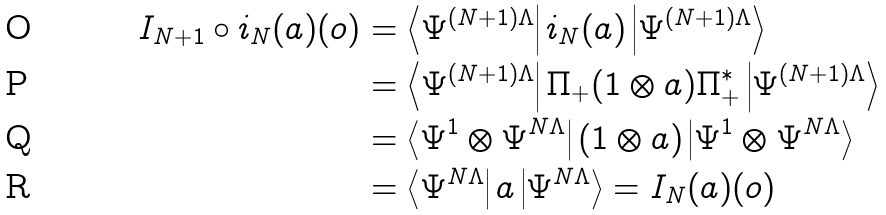<formula> <loc_0><loc_0><loc_500><loc_500>I _ { N + 1 } \circ i _ { N } ( a ) ( o ) & = \left < \Psi ^ { ( N + 1 ) \Lambda } \right | i _ { N } ( a ) \left | \Psi ^ { ( N + 1 ) \Lambda } \right > \\ & = \left < \Psi ^ { ( N + 1 ) \Lambda } \right | \Pi _ { + } ( 1 \otimes a ) \Pi _ { + } ^ { * } \left | \Psi ^ { ( N + 1 ) \Lambda } \right > \\ & = \left < \Psi ^ { 1 } \otimes \Psi ^ { N \Lambda } \right | ( 1 \otimes a ) \left | \Psi ^ { 1 } \otimes \Psi ^ { N \Lambda } \right > \\ & = \left < \Psi ^ { N \Lambda } \right | a \left | \Psi ^ { N \Lambda } \right > = I _ { N } ( a ) ( o )</formula> 